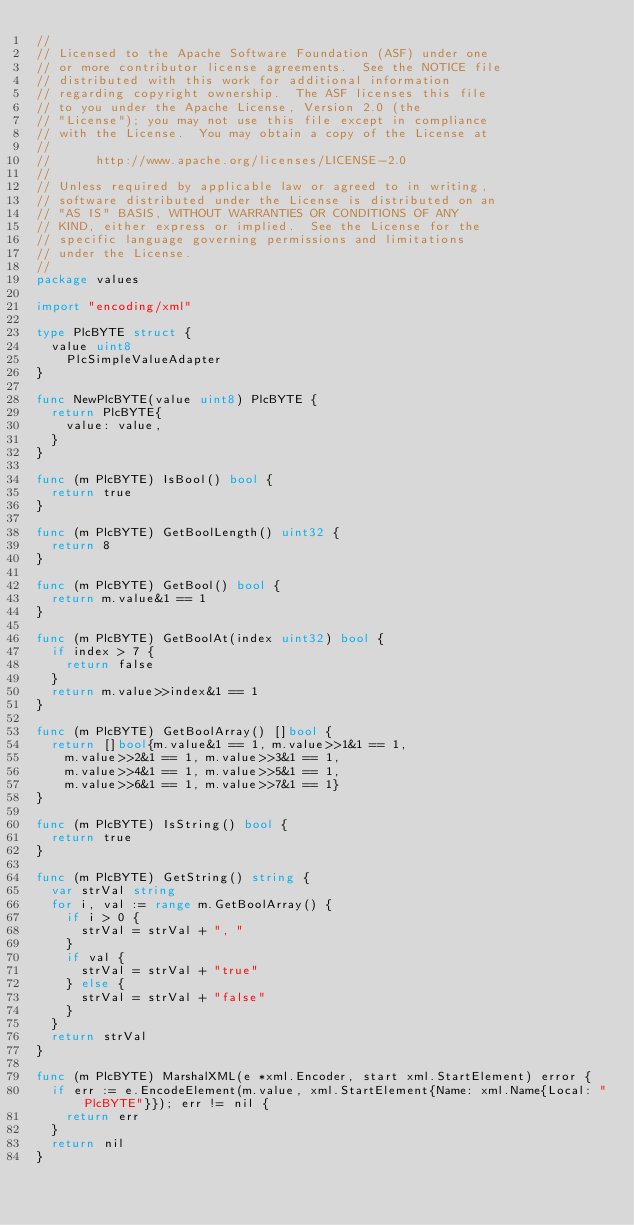Convert code to text. <code><loc_0><loc_0><loc_500><loc_500><_Go_>//
// Licensed to the Apache Software Foundation (ASF) under one
// or more contributor license agreements.  See the NOTICE file
// distributed with this work for additional information
// regarding copyright ownership.  The ASF licenses this file
// to you under the Apache License, Version 2.0 (the
// "License"); you may not use this file except in compliance
// with the License.  You may obtain a copy of the License at
//
//      http://www.apache.org/licenses/LICENSE-2.0
//
// Unless required by applicable law or agreed to in writing,
// software distributed under the License is distributed on an
// "AS IS" BASIS, WITHOUT WARRANTIES OR CONDITIONS OF ANY
// KIND, either express or implied.  See the License for the
// specific language governing permissions and limitations
// under the License.
//
package values

import "encoding/xml"

type PlcBYTE struct {
	value uint8
    PlcSimpleValueAdapter
}

func NewPlcBYTE(value uint8) PlcBYTE {
	return PlcBYTE{
		value: value,
	}
}

func (m PlcBYTE) IsBool() bool {
	return true
}

func (m PlcBYTE) GetBoolLength() uint32 {
	return 8
}

func (m PlcBYTE) GetBool() bool {
	return m.value&1 == 1
}

func (m PlcBYTE) GetBoolAt(index uint32) bool {
	if index > 7 {
		return false
	}
	return m.value>>index&1 == 1
}

func (m PlcBYTE) GetBoolArray() []bool {
	return []bool{m.value&1 == 1, m.value>>1&1 == 1,
		m.value>>2&1 == 1, m.value>>3&1 == 1,
		m.value>>4&1 == 1, m.value>>5&1 == 1,
		m.value>>6&1 == 1, m.value>>7&1 == 1}
}

func (m PlcBYTE) IsString() bool {
	return true
}

func (m PlcBYTE) GetString() string {
	var strVal string
	for i, val := range m.GetBoolArray() {
		if i > 0 {
			strVal = strVal + ", "
		}
		if val {
			strVal = strVal + "true"
		} else {
			strVal = strVal + "false"
		}
	}
	return strVal
}

func (m PlcBYTE) MarshalXML(e *xml.Encoder, start xml.StartElement) error {
	if err := e.EncodeElement(m.value, xml.StartElement{Name: xml.Name{Local: "PlcBYTE"}}); err != nil {
		return err
	}
	return nil
}
</code> 